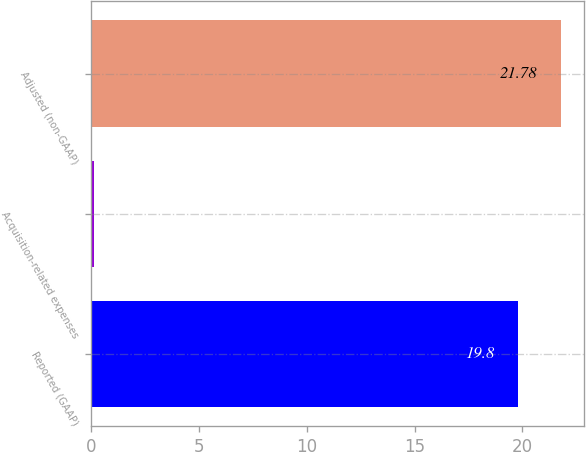<chart> <loc_0><loc_0><loc_500><loc_500><bar_chart><fcel>Reported (GAAP)<fcel>Acquisition-related expenses<fcel>Adjusted (non-GAAP)<nl><fcel>19.8<fcel>0.1<fcel>21.78<nl></chart> 